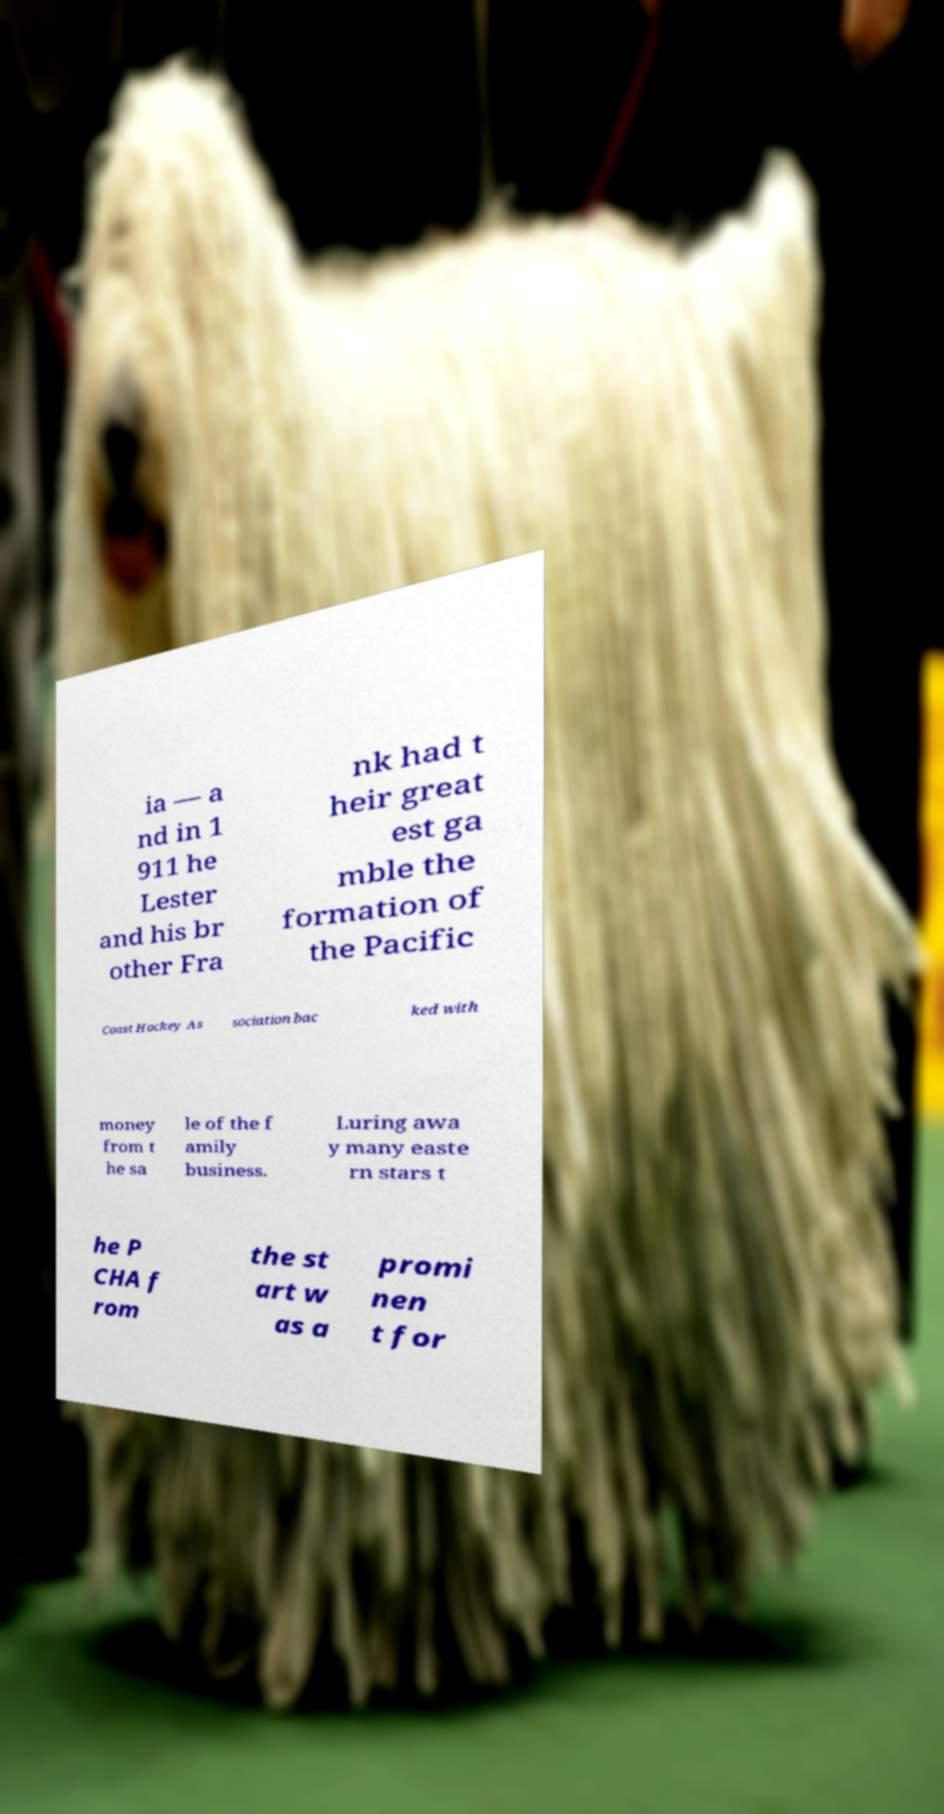Please identify and transcribe the text found in this image. ia — a nd in 1 911 he Lester and his br other Fra nk had t heir great est ga mble the formation of the Pacific Coast Hockey As sociation bac ked with money from t he sa le of the f amily business. Luring awa y many easte rn stars t he P CHA f rom the st art w as a promi nen t for 